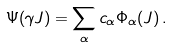<formula> <loc_0><loc_0><loc_500><loc_500>\Psi ( \gamma J ) = \sum _ { \alpha } c _ { \alpha } \Phi _ { \alpha } ( J ) \, .</formula> 